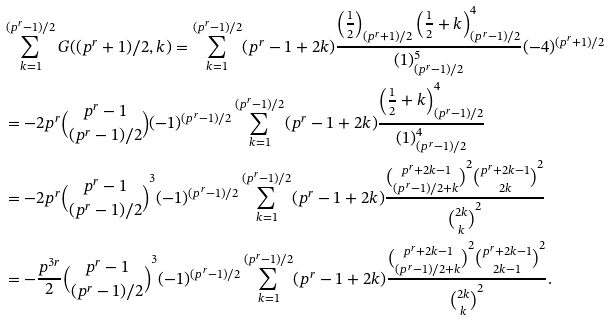<formula> <loc_0><loc_0><loc_500><loc_500>& \sum _ { k = 1 } ^ { ( p ^ { r } - 1 ) / 2 } G ( ( p ^ { r } + 1 ) / 2 , k ) = \sum _ { k = 1 } ^ { ( p ^ { r } - 1 ) / 2 } ( p ^ { r } - 1 + 2 k ) \frac { \left ( \frac { 1 } { 2 } \right ) _ { ( p ^ { r } + 1 ) / 2 } \left ( \frac { 1 } { 2 } + k \right ) ^ { 4 } _ { ( p ^ { r } - 1 ) / 2 } } { ( 1 ) ^ { 5 } _ { ( p ^ { r } - 1 ) / 2 } } ( - 4 ) ^ { ( p ^ { r } + 1 ) / 2 } \\ & = - 2 p ^ { r } \binom { p ^ { r } - 1 } { ( p ^ { r } - 1 ) / 2 } ( - 1 ) ^ { ( p ^ { r } - 1 ) / 2 } \sum _ { k = 1 } ^ { ( p ^ { r } - 1 ) / 2 } ( p ^ { r } - 1 + 2 k ) \frac { \left ( \frac { 1 } { 2 } + k \right ) ^ { 4 } _ { ( p ^ { r } - 1 ) / 2 } } { ( 1 ) ^ { 4 } _ { ( p ^ { r } - 1 ) / 2 } } \\ & = - 2 p ^ { r } \binom { p ^ { r } - 1 } { ( p ^ { r } - 1 ) / 2 } ^ { 3 } ( - 1 ) ^ { ( p ^ { r } - 1 ) / 2 } \sum _ { k = 1 } ^ { ( p ^ { r } - 1 ) / 2 } ( p ^ { r } - 1 + 2 k ) \frac { \binom { p ^ { r } + 2 k - 1 } { ( p ^ { r } - 1 ) / 2 + k } ^ { 2 } \binom { p ^ { r } + 2 k - 1 } { 2 k } ^ { 2 } } { \binom { 2 k } k ^ { 2 } } \\ & = - \frac { p ^ { 3 r } } 2 \binom { p ^ { r } - 1 } { ( p ^ { r } - 1 ) / 2 } ^ { 3 } ( - 1 ) ^ { ( p ^ { r } - 1 ) / 2 } \sum _ { k = 1 } ^ { ( p ^ { r } - 1 ) / 2 } ( p ^ { r } - 1 + 2 k ) \frac { \binom { p ^ { r } + 2 k - 1 } { ( p ^ { r } - 1 ) / 2 + k } ^ { 2 } \binom { p ^ { r } + 2 k - 1 } { 2 k - 1 } ^ { 2 } } { \binom { 2 k } k ^ { 2 } } .</formula> 